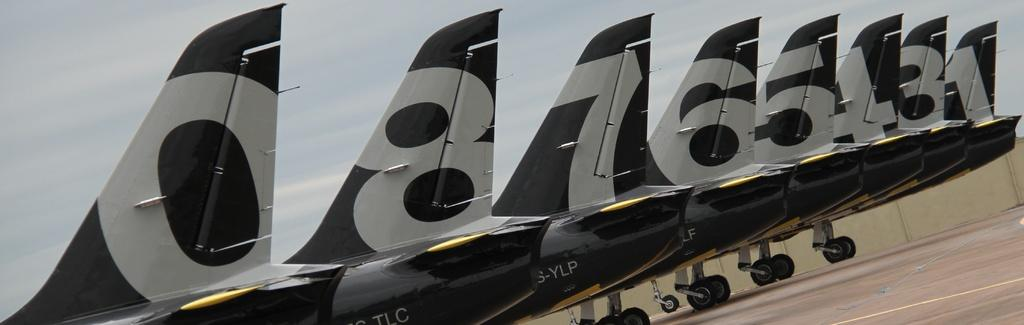What type of vehicles are on the ground in the image? There are aircraft on the ground in the image. What can be seen in the background of the image? The sky is visible in the background of the image. What type of veil is draped over the aircraft in the image? There is no veil present in the image; the aircraft are not covered or draped. 